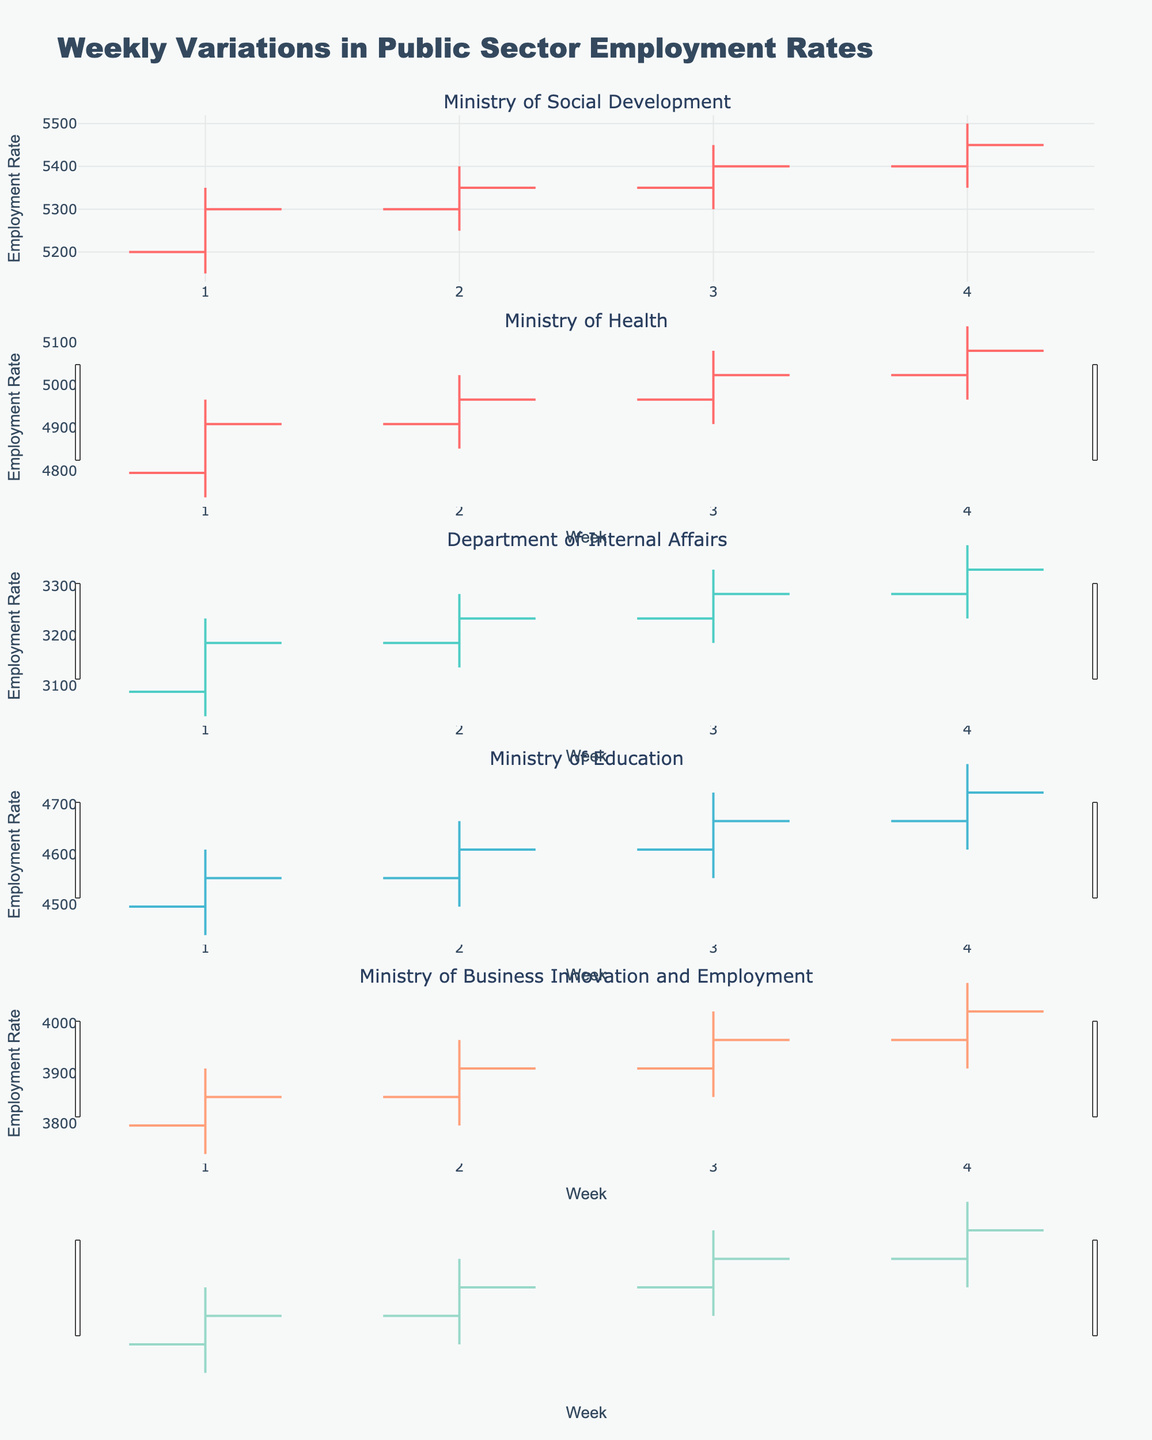What's the title of the figure? The title is indicated at the top of the figure and reads "Weekly Variations in Public Sector Employment Rates".
Answer: Weekly Variations in Public Sector Employment Rates Which department had the highest employment rate in Week 4? Look at the Week 4 data for all departments and compare the 'High' values. Ministry of Social Development has the highest 'High' value of 5500.
Answer: Ministry of Social Development What was the overall range of employment rates for the Ministry of Health in Week 3? For Week 3, the 'High' value is 5050 and the 'Low' value is 4900. The range is calculated as 5050 - 4900.
Answer: 150 Did any department show a decrease in employment rate from Week 1 to Week 4? Compare the 'Close' values of Week 1 and Week 4 for each department. All departments have a higher or equal 'Close' value in Week 4 compared to Week 1.
Answer: No What is the difference in the 'Close' values between Week 4 and Week 1 for the Ministry of Business Innovation and Employment? The 'Close' value in Week 4 is 4000 and in Week 1 is 3850. The difference is 4000 - 3850.
Answer: 150 Which department experienced the smallest weekly range in Week 2? Determine the range by subtracting 'Low' from 'High' for each department in Week 2. Department of Internal Affairs has the smallest range: 3250 - 3100 = 150.
Answer: Department of Internal Affairs What is the average 'Close' value for the Ministry of Education over all weeks? Add the 'Close' values for all weeks (4550, 4600, 4650, 4700) and divide by the number of weeks (4). (4550 + 4600 + 4650 + 4700) / 4 = 4625.
Answer: 4625 Which department showed the highest 'Open' value in Week 1? Review 'Open' values for all departments in Week 1. Ministry of Social Development has the highest 'Open' value at 5200.
Answer: Ministry of Social Development Did the employment rate for the Department of Internal Affairs ever decrease over the weeks? Compare the 'Close' values sequentially from Week 1 to Week 4 for Department of Internal Affairs. The 'Close' value consistently increases or remains constant.
Answer: No 